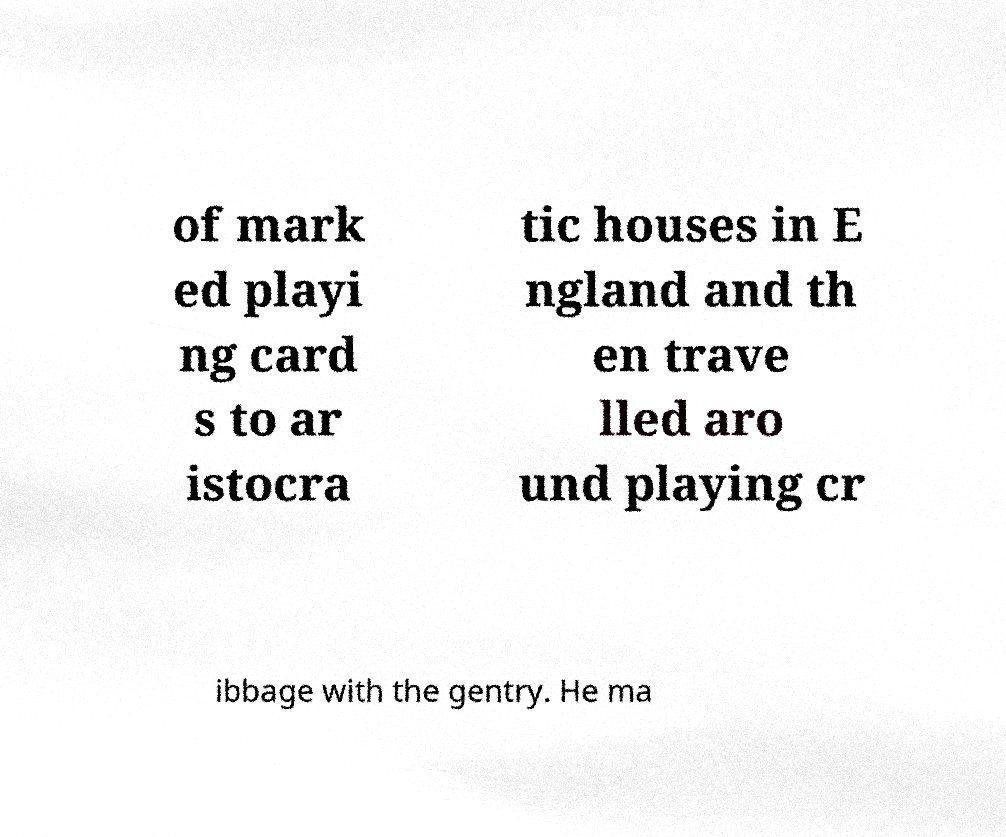What messages or text are displayed in this image? I need them in a readable, typed format. of mark ed playi ng card s to ar istocra tic houses in E ngland and th en trave lled aro und playing cr ibbage with the gentry. He ma 